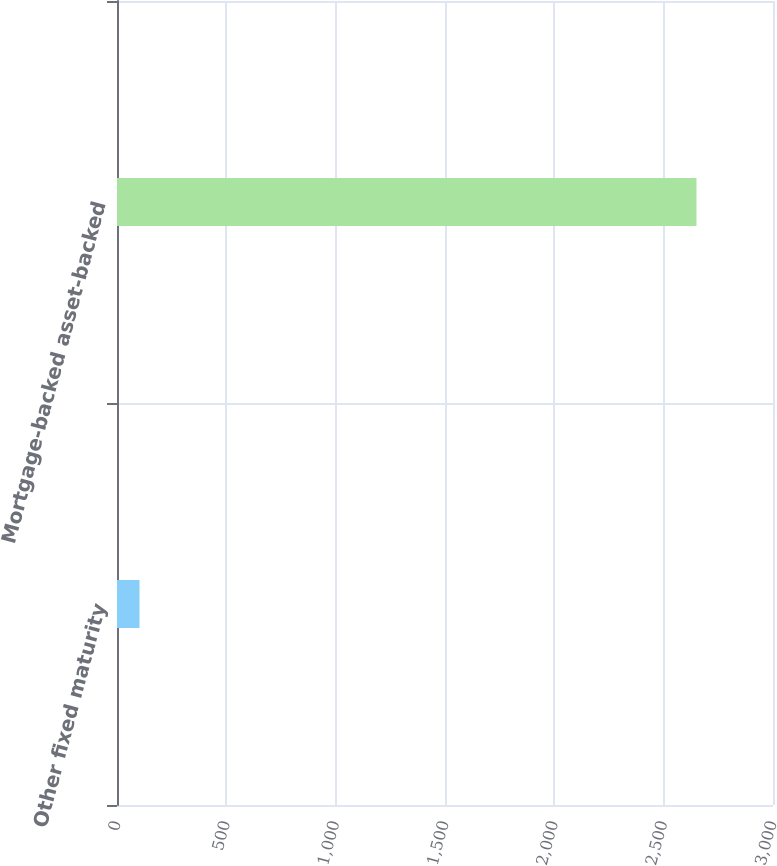Convert chart. <chart><loc_0><loc_0><loc_500><loc_500><bar_chart><fcel>Other fixed maturity<fcel>Mortgage-backed asset-backed<nl><fcel>103<fcel>2650<nl></chart> 